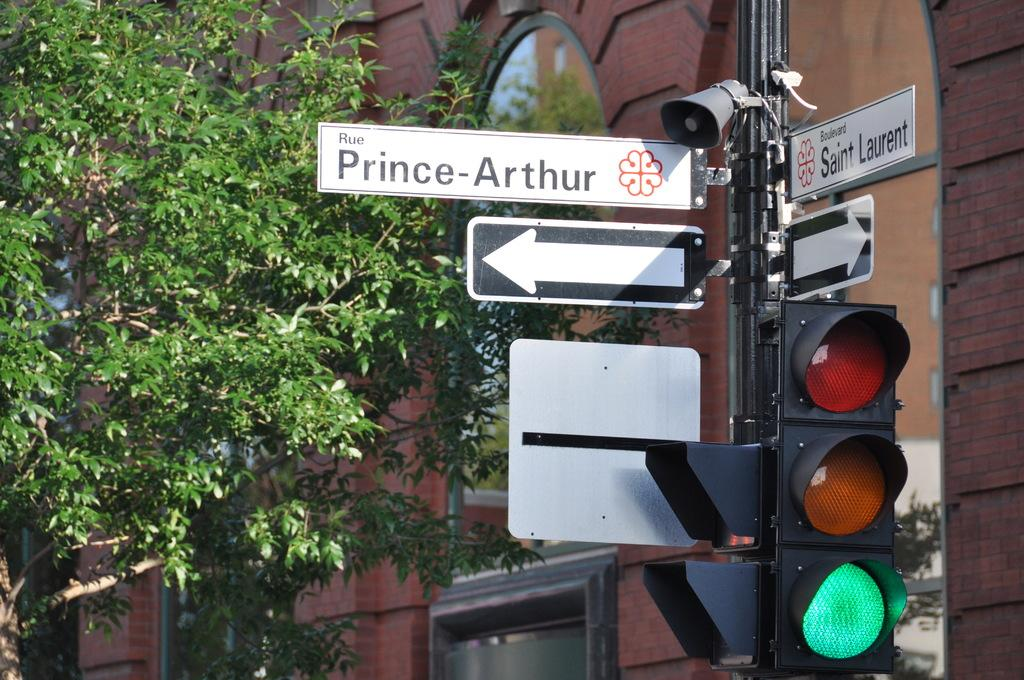<image>
Create a compact narrative representing the image presented. A traffic light is on the corner of Rue Prince Arthur and Boulevard Saint Laurent. 